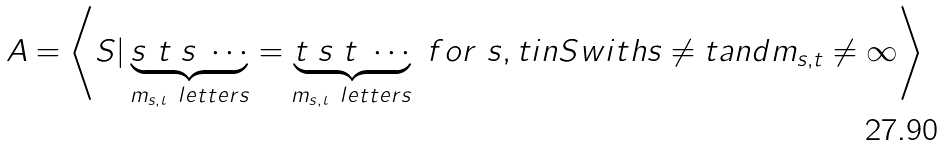<formula> <loc_0><loc_0><loc_500><loc_500>A = \left < S | \underbrace { s \ t \ s \ \cdots } _ { m _ { s , t } \ l e t t e r s } = \underbrace { t \ s \ t \ \cdots } _ { m _ { s , t } \ l e t t e r s } \ f o r \ s , t i n S w i t h s \neq t a n d m _ { s , t } \neq \infty \right ></formula> 